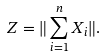<formula> <loc_0><loc_0><loc_500><loc_500>Z = \| \sum _ { i = 1 } ^ { n } X _ { i } \| .</formula> 